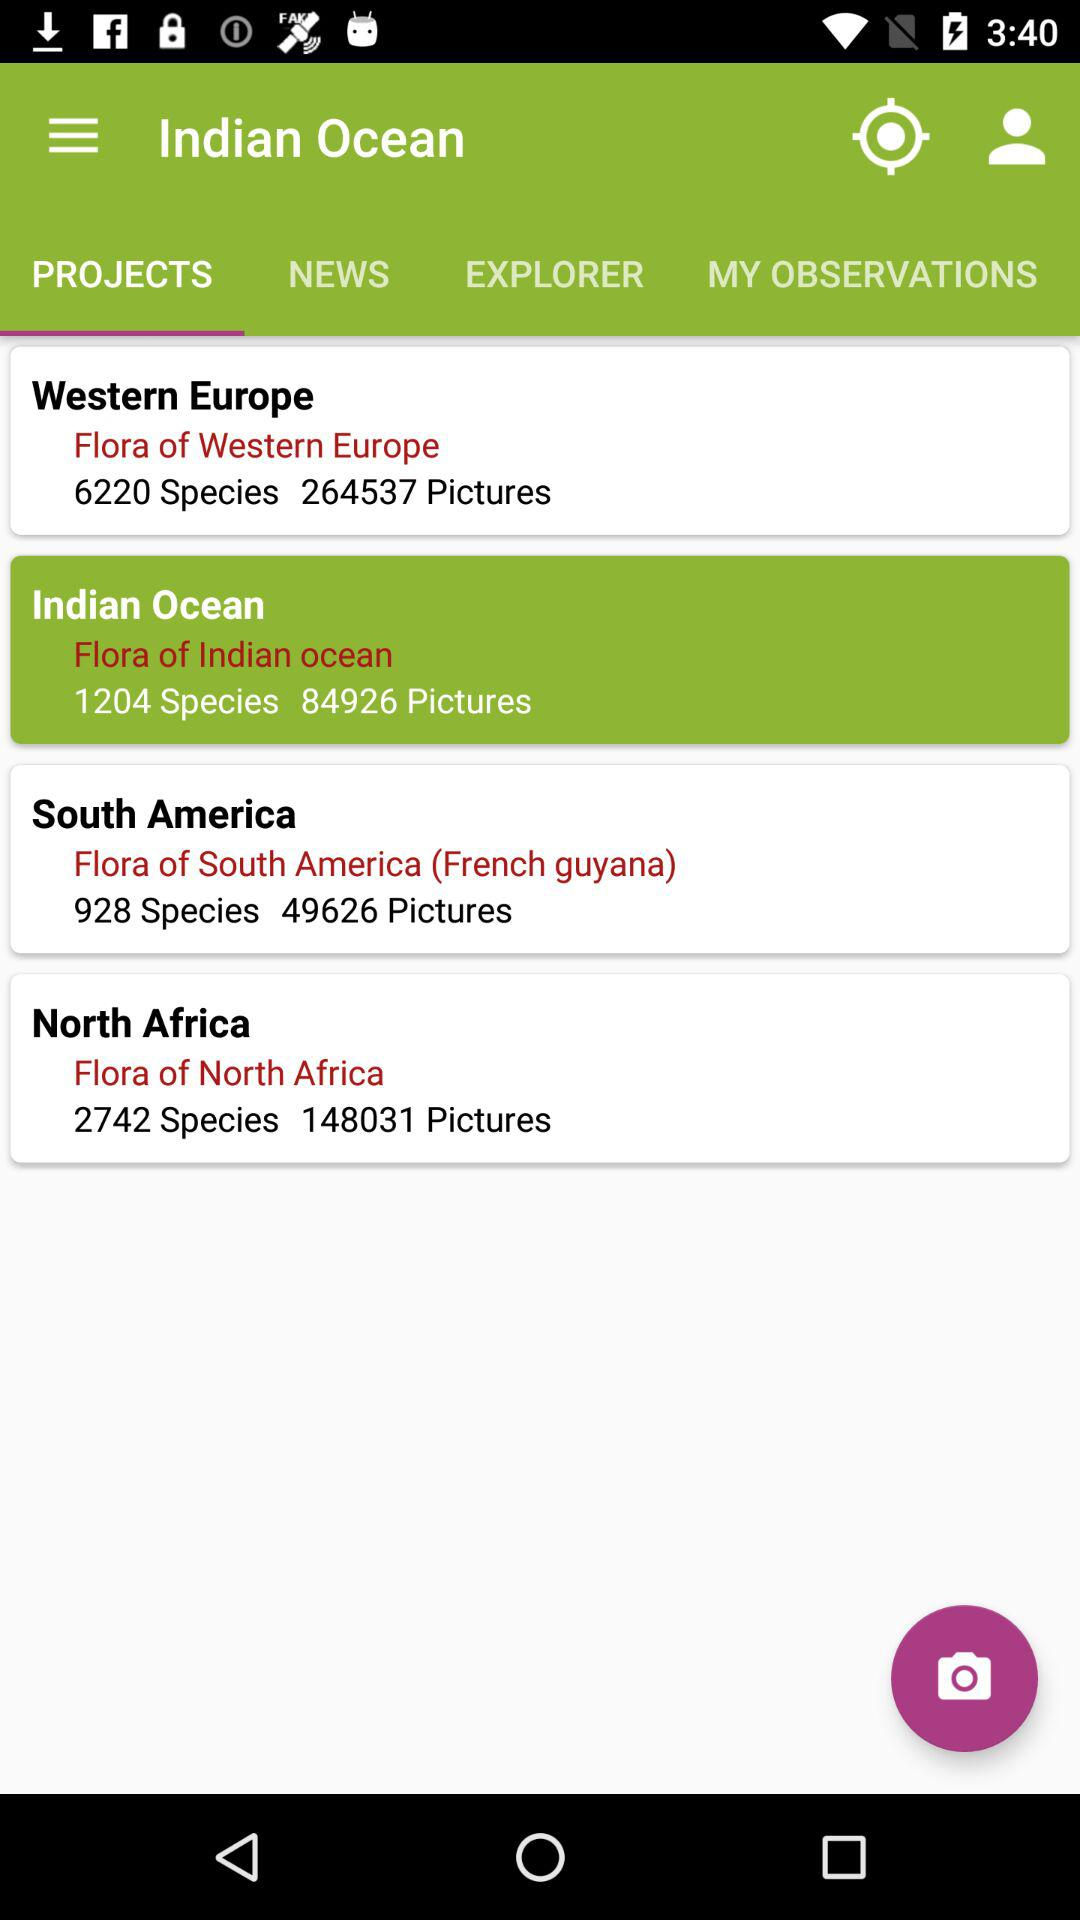Which tab am I on? You are on the "PROJECTS" tab. 